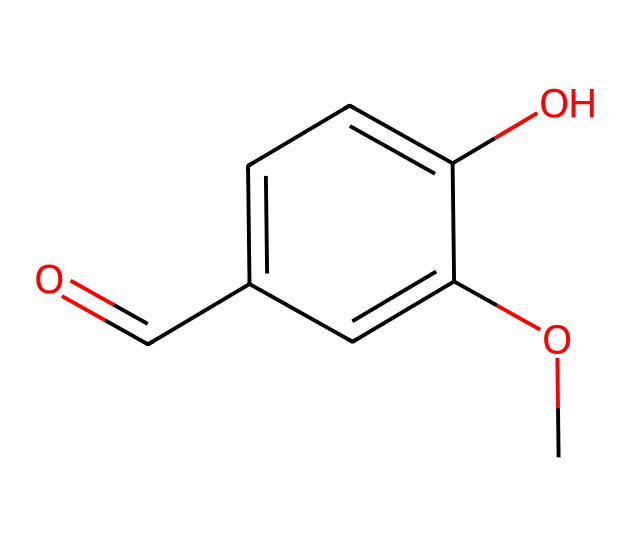What is the name of this chemical? The SMILES representation indicates that the structure corresponds to vanillin, which is commonly known as a flavoring agent.
Answer: vanillin How many carbon atoms are in this molecule? By analyzing the SMILES representation, we can count the number of carbon atoms in the molecular structure; there are 8 carbon atoms (C).
Answer: 8 What kind of functional group is present in this compound? The presence of the -OH group in the structure indicates that this molecule features a hydroxyl functional group, which is characteristic of phenolic compounds.
Answer: hydroxyl Identify the type of compound this molecule is classified as. Given the structure, this molecule falls into the category of aromatic aldehydes due to the presence of the aromatic ring and the aldehyde functional group (C=O).
Answer: aromatic aldehyde What properties does vanillin contribute to energy bars? As a flavoring agent, vanillin provides a sweet and pleasant vanilla flavor, enhancing the sensory experience of energy bars consumed by athletes.
Answer: flavoring agent Which part of this molecule is responsible for its sweet flavor? The aldehyde functional group (C=O) is key; it contributes to the characteristic sweet flavor of vanillin, enhancing its sensory attributes.
Answer: aldehyde functional group How many oxygen atoms are in the molecular structure of vanillin? The SMILES indicates that there are 3 oxygen atoms (O) present in the structure, which include those in both hydroxyl and carbonyl groups.
Answer: 3 